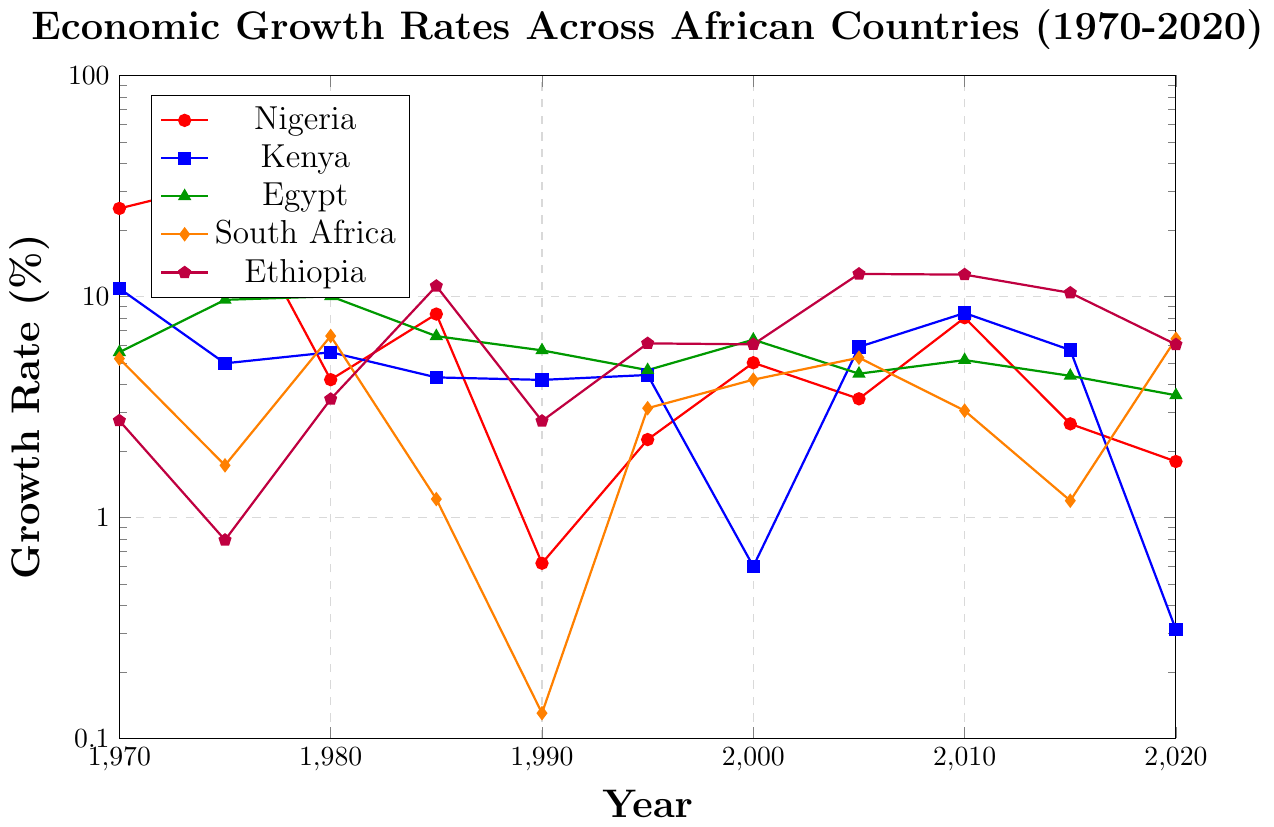Which country had the highest growth rate in 2005? We inspect the growth rates for all countries in 2005: Nigeria (3.44), Kenya (5.91), Egypt (4.47), South Africa (5.28), Ethiopia (12.64). Ethiopia has the highest rate.
Answer: Ethiopia Did Kenya experience a positive or negative growth rate in 2020? We look at Kenya's growth rate in 2020, which is -0.31, indicating a negative value.
Answer: Negative Between 1980 and 1985, which country experienced the largest decrease in growth rate? By comparing the growth rates of each country between 1980 and 1985: Nigeria (4.2 to 8.32), Kenya (5.59 to 4.3), Egypt (10.01 to 6.61), South Africa (6.62 to -1.21), Ethiopia (3.43 to -11.14). South Africa’s decrease of 7.83 (6.62 - (-1.21)) is the largest.
Answer: South Africa What is the average growth rate of Egypt over the period 1970 to 2020? We sum Egypt's growth rates over the years (5.59 + 9.65 + 10.01 + 6.61 + 5.7 + 4.64 + 6.37 + 4.47 + 5.15 + 4.37 + 3.57) and divide by the number of years (11): (5.59 + 9.65 + 10.01 + 6.61 + 5.7 + 4.64 + 6.37 + 4.47 + 5.15 + 4.37 + 3.57) / 11 = 5.82
Answer: 5.82 Which two countries had equal growth rates in 1990? By comparing the growth rates in 1990: Nigeria (-0.62), Kenya (4.19), Egypt (5.7), South Africa (0.13), Ethiopia (2.73), no two countries have the same growth rate.
Answer: None In which year did Ethiopia achieve the highest growth rate, and what was the value? We check Ethiopia’s year-by-year data to find the maximum value in 2005, which is 12.64.
Answer: 2005, 12.64 Did South Africa show a consistent growth trend from 1970 to 2020? Analyzing South Africa’s growth rates: 5.23, 1.72, 6.62, -1.21, 0.13, 3.12, 4.2, 5.28, 3.04, 1.19, -6.43, the trend is inconsistent with both positive and negative changes.
Answer: No What is the median growth rate for Kenya from 1970 to 2020? Arranging Kenya's rates in ascending order: -0.31, 0.6, 4.19, 4.3, 4.41, 4.98, 5.59, 5.72, 5.91, 8.41, median growth rate is the 6th value, which is 4.98.
Answer: 4.98 How did Nigeria's growth rate change from 1980 to 1985? Nigeria's growth rate in 1980 is 4.2 and in 1985 is 8.32. It increased by 8.32 - 4.2 = 4.12%.
Answer: Increased by 4.12% 